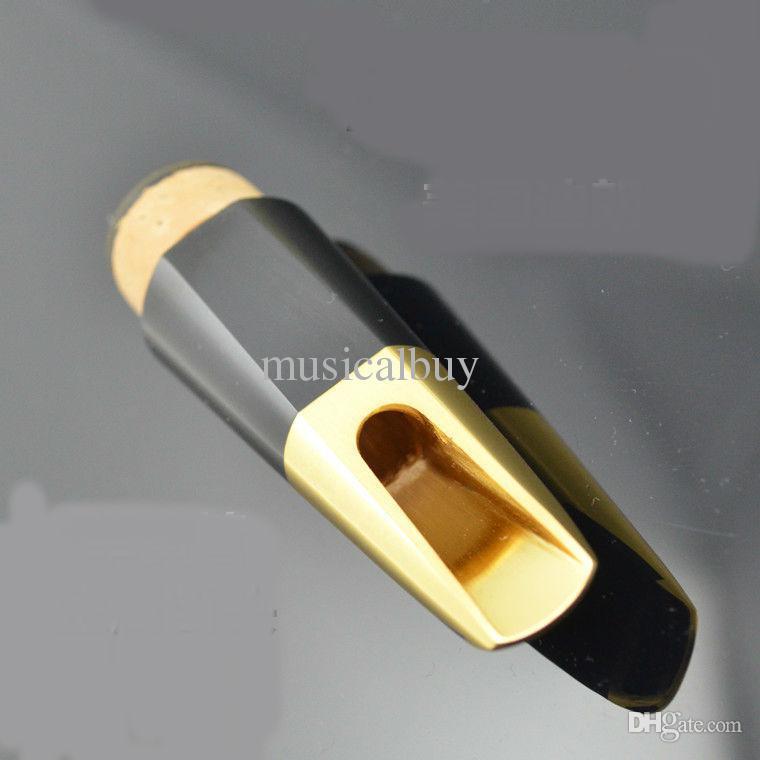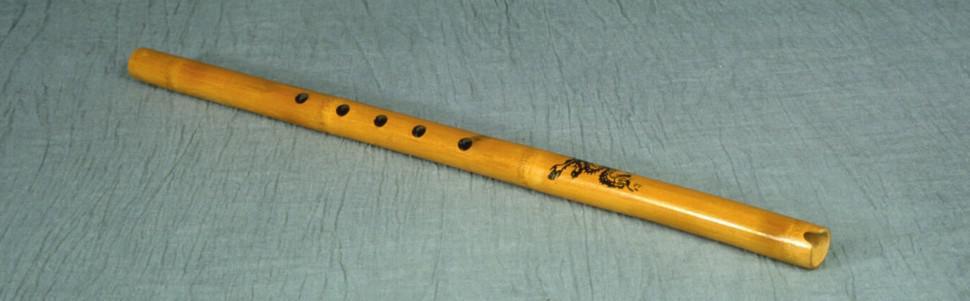The first image is the image on the left, the second image is the image on the right. Assess this claim about the two images: "The right image shows a silver tube angled upward to the right, with a gold oblong shape with a hole in it near the middle of the tube.". Correct or not? Answer yes or no. No. The first image is the image on the left, the second image is the image on the right. Given the left and right images, does the statement "In the right image, the instrument mouthpiece is gold colored on a silver body." hold true? Answer yes or no. No. 